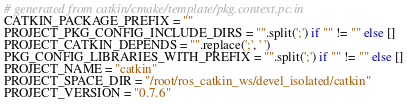<code> <loc_0><loc_0><loc_500><loc_500><_Python_># generated from catkin/cmake/template/pkg.context.pc.in
CATKIN_PACKAGE_PREFIX = ""
PROJECT_PKG_CONFIG_INCLUDE_DIRS = "".split(';') if "" != "" else []
PROJECT_CATKIN_DEPENDS = "".replace(';', ' ')
PKG_CONFIG_LIBRARIES_WITH_PREFIX = "".split(';') if "" != "" else []
PROJECT_NAME = "catkin"
PROJECT_SPACE_DIR = "/root/ros_catkin_ws/devel_isolated/catkin"
PROJECT_VERSION = "0.7.6"
</code> 